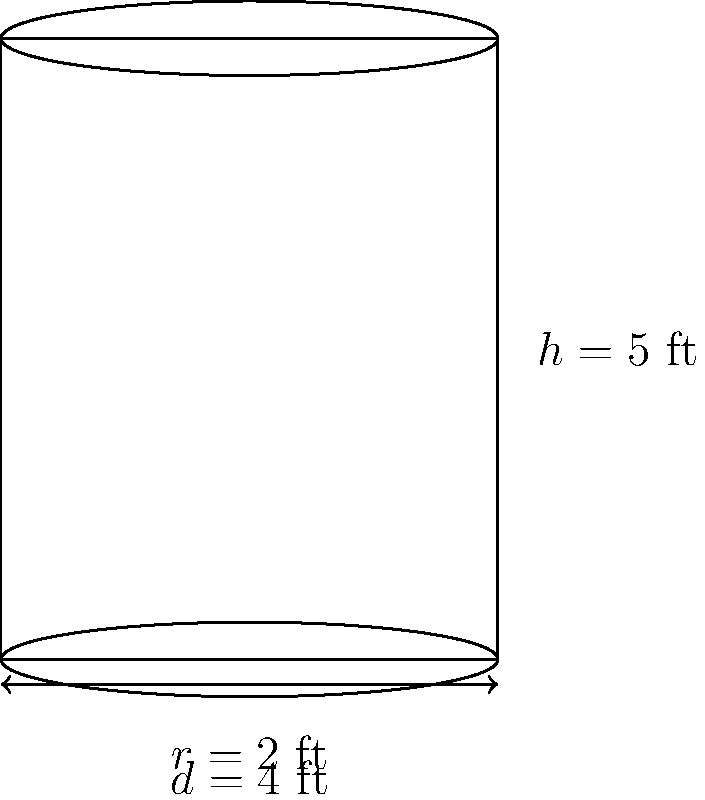A cylindrical trash can in the city park needs to be coated with anti-graffiti paint. The can has a diameter of 4 feet and a height of 5 feet. How many square feet of anti-graffiti coating is needed to cover the entire exterior surface of the trash can, including the top and bottom? Round your answer to the nearest tenth of a square foot. To solve this problem, we need to calculate the total surface area of the cylindrical trash can. This includes the lateral surface area (sides) and the area of the top and bottom circles.

Step 1: Calculate the circumference of the base
The diameter is 4 feet, so the radius $r = 2$ feet.
Circumference $= 2\pi r = 2\pi(2) = 4\pi$ feet

Step 2: Calculate the lateral surface area
Lateral surface area $= \text{circumference} \times \text{height} = 4\pi \times 5 = 20\pi$ square feet

Step 3: Calculate the area of the top and bottom circles
Area of one circle $= \pi r^2 = \pi(2^2) = 4\pi$ square feet
Area of both circles $= 2 \times 4\pi = 8\pi$ square feet

Step 4: Calculate the total surface area
Total surface area $= \text{lateral surface area} + \text{area of top and bottom}$
$= 20\pi + 8\pi = 28\pi$ square feet

Step 5: Convert to a numerical value and round to the nearest tenth
$28\pi \approx 87.9645...$ square feet
Rounded to the nearest tenth: 88.0 square feet
Answer: 88.0 sq ft 